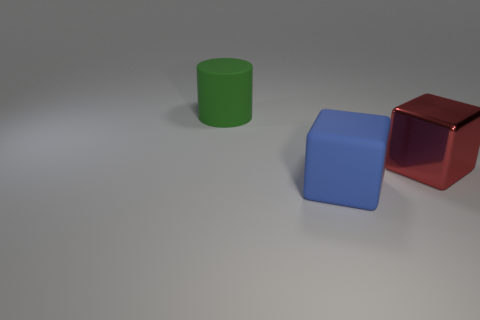Do the object that is right of the large blue rubber block and the big green rubber object have the same shape?
Provide a succinct answer. No. What material is the other blue thing that is the same shape as the large metallic thing?
Your response must be concise. Rubber. What number of things are big objects that are right of the blue matte cube or large things in front of the large green thing?
Your answer should be compact. 2. There is a metallic cube; does it have the same color as the rubber thing that is behind the red shiny cube?
Your answer should be very brief. No. There is a blue thing that is made of the same material as the big cylinder; what is its shape?
Make the answer very short. Cube. How many matte things are there?
Your answer should be compact. 2. How many objects are either large rubber objects behind the large blue cube or yellow matte objects?
Offer a terse response. 1. Is the color of the big rubber object that is behind the blue object the same as the large metallic cube?
Make the answer very short. No. How many other things are there of the same color as the big cylinder?
Offer a terse response. 0. What number of big things are either green objects or blue cubes?
Offer a terse response. 2. 